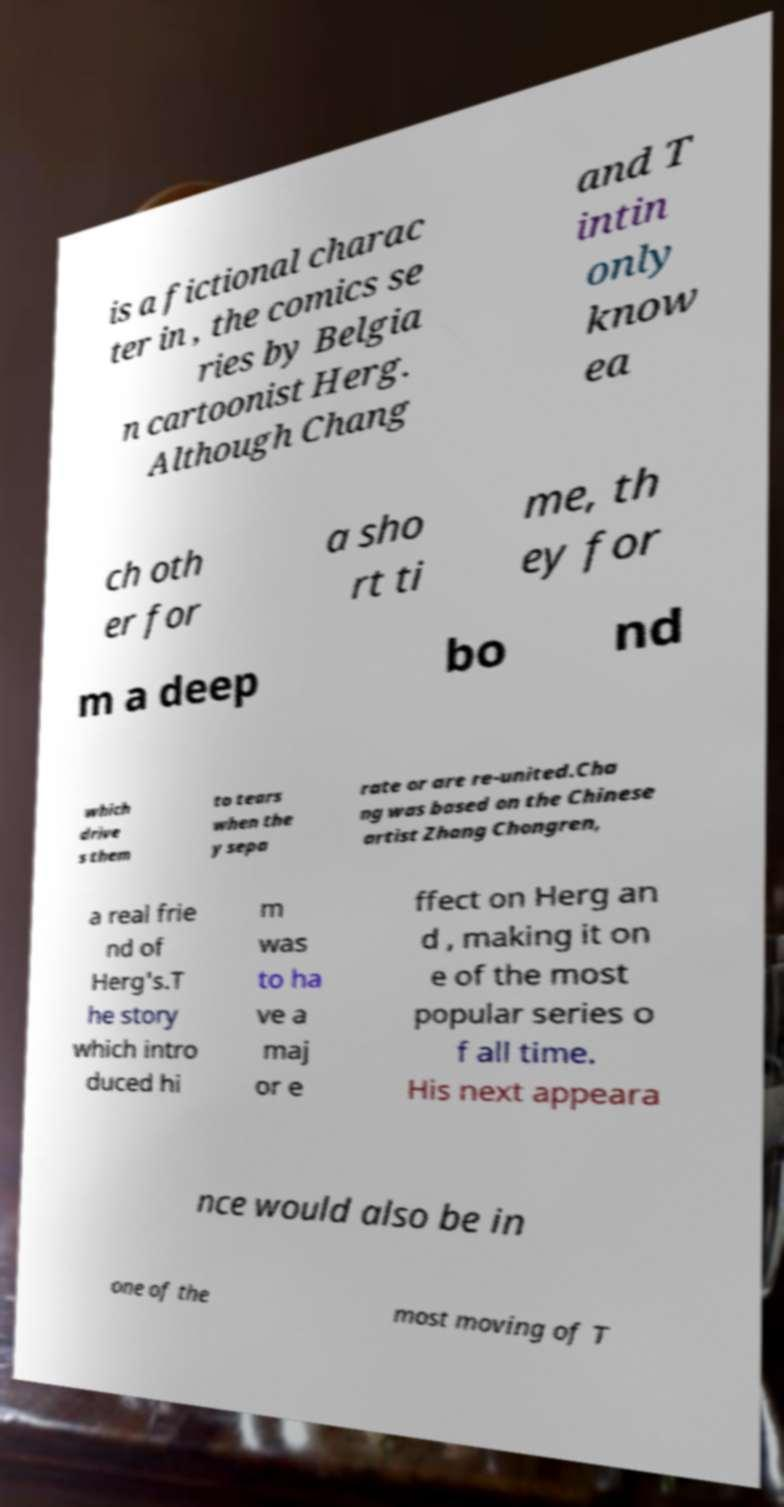There's text embedded in this image that I need extracted. Can you transcribe it verbatim? is a fictional charac ter in , the comics se ries by Belgia n cartoonist Herg. Although Chang and T intin only know ea ch oth er for a sho rt ti me, th ey for m a deep bo nd which drive s them to tears when the y sepa rate or are re-united.Cha ng was based on the Chinese artist Zhang Chongren, a real frie nd of Herg's.T he story which intro duced hi m was to ha ve a maj or e ffect on Herg an d , making it on e of the most popular series o f all time. His next appeara nce would also be in one of the most moving of T 